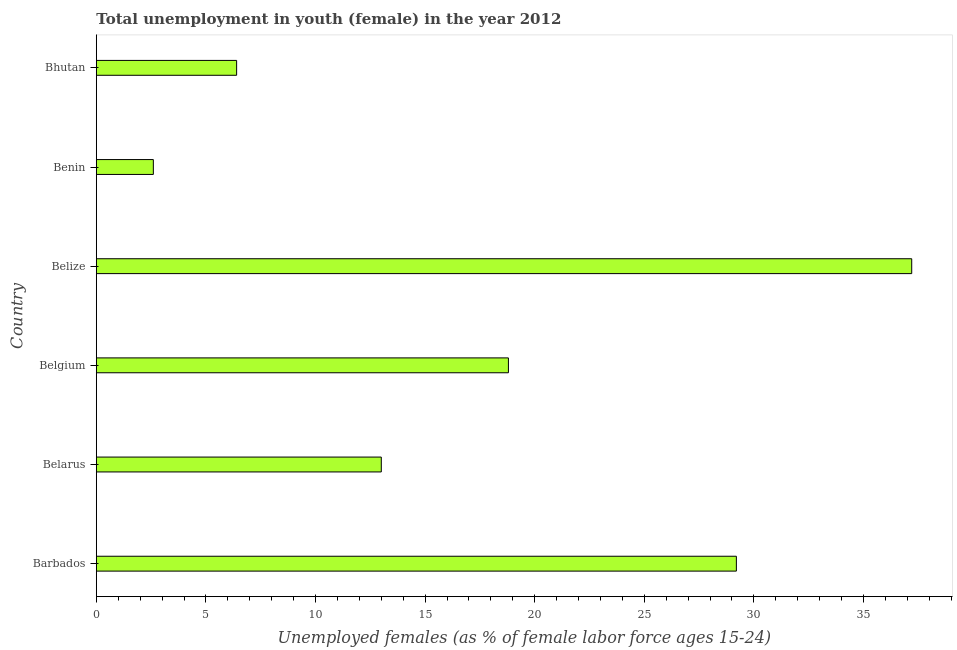What is the title of the graph?
Make the answer very short. Total unemployment in youth (female) in the year 2012. What is the label or title of the X-axis?
Provide a succinct answer. Unemployed females (as % of female labor force ages 15-24). What is the unemployed female youth population in Belarus?
Your response must be concise. 13. Across all countries, what is the maximum unemployed female youth population?
Offer a very short reply. 37.2. Across all countries, what is the minimum unemployed female youth population?
Give a very brief answer. 2.6. In which country was the unemployed female youth population maximum?
Your answer should be very brief. Belize. In which country was the unemployed female youth population minimum?
Keep it short and to the point. Benin. What is the sum of the unemployed female youth population?
Offer a terse response. 107.2. What is the difference between the unemployed female youth population in Barbados and Belize?
Your answer should be compact. -8. What is the average unemployed female youth population per country?
Provide a short and direct response. 17.87. What is the median unemployed female youth population?
Your answer should be very brief. 15.9. In how many countries, is the unemployed female youth population greater than 8 %?
Provide a succinct answer. 4. What is the ratio of the unemployed female youth population in Belize to that in Benin?
Keep it short and to the point. 14.31. Is the unemployed female youth population in Barbados less than that in Benin?
Keep it short and to the point. No. What is the difference between the highest and the second highest unemployed female youth population?
Ensure brevity in your answer.  8. What is the difference between the highest and the lowest unemployed female youth population?
Provide a succinct answer. 34.6. How many bars are there?
Your answer should be very brief. 6. How many countries are there in the graph?
Offer a terse response. 6. What is the Unemployed females (as % of female labor force ages 15-24) in Barbados?
Your answer should be compact. 29.2. What is the Unemployed females (as % of female labor force ages 15-24) of Belgium?
Ensure brevity in your answer.  18.8. What is the Unemployed females (as % of female labor force ages 15-24) in Belize?
Keep it short and to the point. 37.2. What is the Unemployed females (as % of female labor force ages 15-24) in Benin?
Ensure brevity in your answer.  2.6. What is the Unemployed females (as % of female labor force ages 15-24) in Bhutan?
Keep it short and to the point. 6.4. What is the difference between the Unemployed females (as % of female labor force ages 15-24) in Barbados and Belize?
Your answer should be compact. -8. What is the difference between the Unemployed females (as % of female labor force ages 15-24) in Barbados and Benin?
Offer a very short reply. 26.6. What is the difference between the Unemployed females (as % of female labor force ages 15-24) in Barbados and Bhutan?
Your answer should be very brief. 22.8. What is the difference between the Unemployed females (as % of female labor force ages 15-24) in Belarus and Belize?
Your answer should be very brief. -24.2. What is the difference between the Unemployed females (as % of female labor force ages 15-24) in Belarus and Benin?
Offer a very short reply. 10.4. What is the difference between the Unemployed females (as % of female labor force ages 15-24) in Belgium and Belize?
Provide a succinct answer. -18.4. What is the difference between the Unemployed females (as % of female labor force ages 15-24) in Belgium and Benin?
Provide a short and direct response. 16.2. What is the difference between the Unemployed females (as % of female labor force ages 15-24) in Belize and Benin?
Make the answer very short. 34.6. What is the difference between the Unemployed females (as % of female labor force ages 15-24) in Belize and Bhutan?
Your answer should be compact. 30.8. What is the ratio of the Unemployed females (as % of female labor force ages 15-24) in Barbados to that in Belarus?
Ensure brevity in your answer.  2.25. What is the ratio of the Unemployed females (as % of female labor force ages 15-24) in Barbados to that in Belgium?
Offer a terse response. 1.55. What is the ratio of the Unemployed females (as % of female labor force ages 15-24) in Barbados to that in Belize?
Your answer should be very brief. 0.79. What is the ratio of the Unemployed females (as % of female labor force ages 15-24) in Barbados to that in Benin?
Ensure brevity in your answer.  11.23. What is the ratio of the Unemployed females (as % of female labor force ages 15-24) in Barbados to that in Bhutan?
Provide a short and direct response. 4.56. What is the ratio of the Unemployed females (as % of female labor force ages 15-24) in Belarus to that in Belgium?
Make the answer very short. 0.69. What is the ratio of the Unemployed females (as % of female labor force ages 15-24) in Belarus to that in Belize?
Keep it short and to the point. 0.35. What is the ratio of the Unemployed females (as % of female labor force ages 15-24) in Belarus to that in Benin?
Offer a terse response. 5. What is the ratio of the Unemployed females (as % of female labor force ages 15-24) in Belarus to that in Bhutan?
Offer a very short reply. 2.03. What is the ratio of the Unemployed females (as % of female labor force ages 15-24) in Belgium to that in Belize?
Make the answer very short. 0.51. What is the ratio of the Unemployed females (as % of female labor force ages 15-24) in Belgium to that in Benin?
Make the answer very short. 7.23. What is the ratio of the Unemployed females (as % of female labor force ages 15-24) in Belgium to that in Bhutan?
Offer a very short reply. 2.94. What is the ratio of the Unemployed females (as % of female labor force ages 15-24) in Belize to that in Benin?
Your answer should be very brief. 14.31. What is the ratio of the Unemployed females (as % of female labor force ages 15-24) in Belize to that in Bhutan?
Make the answer very short. 5.81. What is the ratio of the Unemployed females (as % of female labor force ages 15-24) in Benin to that in Bhutan?
Offer a very short reply. 0.41. 